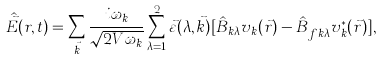Convert formula to latex. <formula><loc_0><loc_0><loc_500><loc_500>\hat { \vec { E } } ( r , t ) = \sum _ { \vec { k } } \frac { i \omega _ { k } } { \sqrt { 2 V \omega _ { k } } } \sum _ { \lambda = 1 } ^ { 2 } \vec { \varepsilon } ( \lambda , \vec { k } ) [ \hat { B } _ { k \lambda } v _ { k } ( \vec { r } ) - \hat { B } ^ { \dag } _ { f k \lambda } v _ { k } ^ { \ast } ( \vec { r } ) ] ,</formula> 